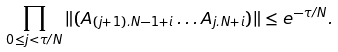<formula> <loc_0><loc_0><loc_500><loc_500>\prod _ { 0 \leq j < \tau / N } \| ( A _ { ( j + 1 ) . N - 1 + i } \dots A _ { j . N + i } ) \| \leq e ^ { - \tau / N } .</formula> 